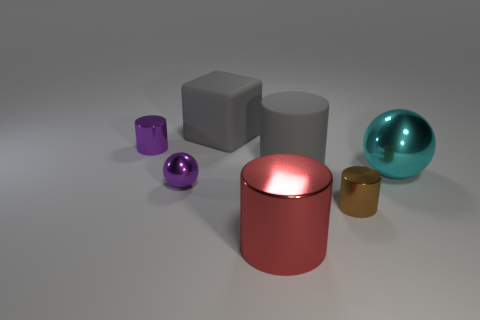Is the red shiny thing the same size as the cyan metallic object? While the red canister appears larger due to its closer proximity in the image, comparing their relative sizes suggests that the red canister and the cyan sphere are quite similar in diameter; however, due to perspective and lack of a common reference point, it's not possible to determine if they are exactly the same size without further context or measurement. 